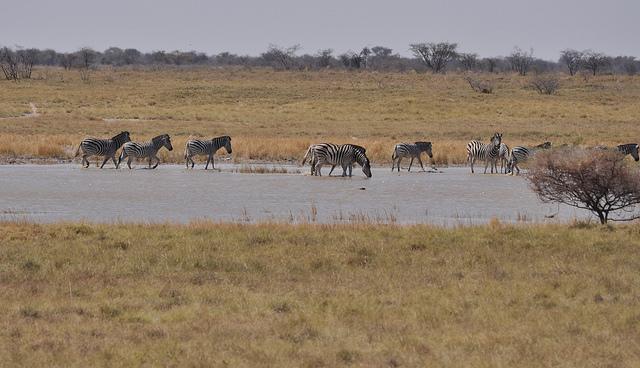What are the zebras all standing inside of?
Choose the correct response, then elucidate: 'Answer: answer
Rationale: rationale.'
Options: Grass, dirt, stream, lake. Answer: stream.
Rationale: Animals are standing in a small body of water with land on two sides. What direction are the animals facing?
Select the accurate answer and provide justification: `Answer: choice
Rationale: srationale.`
Options: South, west, east, north. Answer: east.
Rationale: The zebras are facing to the right. 